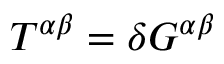Convert formula to latex. <formula><loc_0><loc_0><loc_500><loc_500>T ^ { \alpha \beta } = \delta G ^ { \alpha \beta }</formula> 